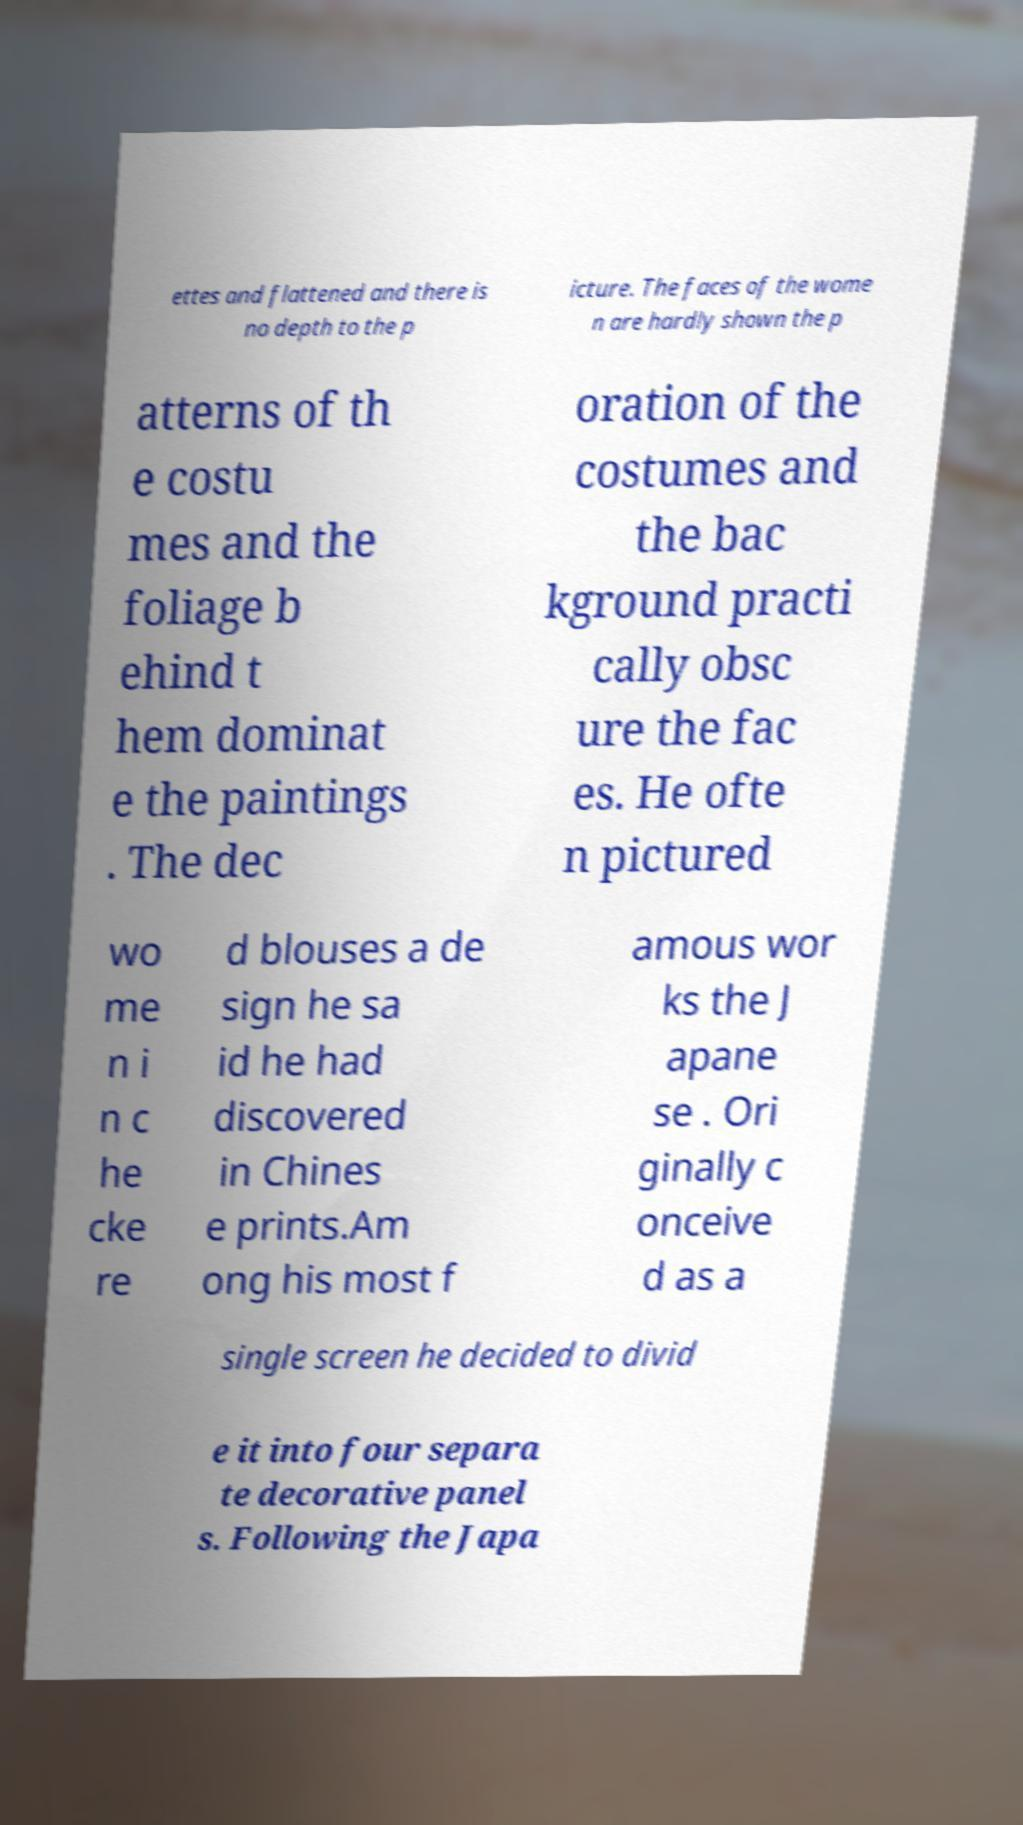Could you extract and type out the text from this image? ettes and flattened and there is no depth to the p icture. The faces of the wome n are hardly shown the p atterns of th e costu mes and the foliage b ehind t hem dominat e the paintings . The dec oration of the costumes and the bac kground practi cally obsc ure the fac es. He ofte n pictured wo me n i n c he cke re d blouses a de sign he sa id he had discovered in Chines e prints.Am ong his most f amous wor ks the J apane se . Ori ginally c onceive d as a single screen he decided to divid e it into four separa te decorative panel s. Following the Japa 